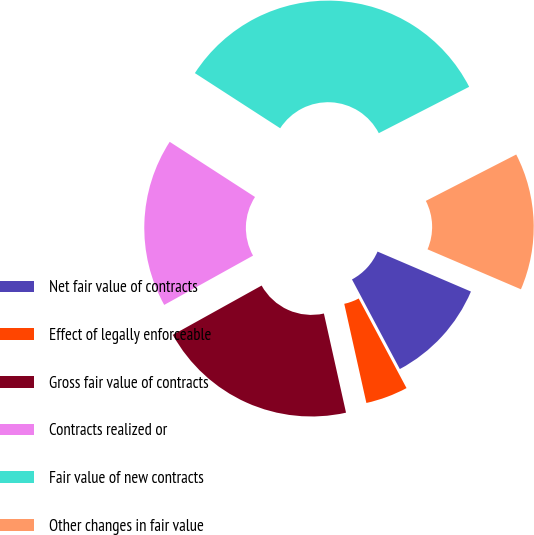<chart> <loc_0><loc_0><loc_500><loc_500><pie_chart><fcel>Net fair value of contracts<fcel>Effect of legally enforceable<fcel>Gross fair value of contracts<fcel>Contracts realized or<fcel>Fair value of new contracts<fcel>Other changes in fair value<nl><fcel>10.76%<fcel>4.31%<fcel>20.43%<fcel>17.2%<fcel>33.32%<fcel>13.98%<nl></chart> 